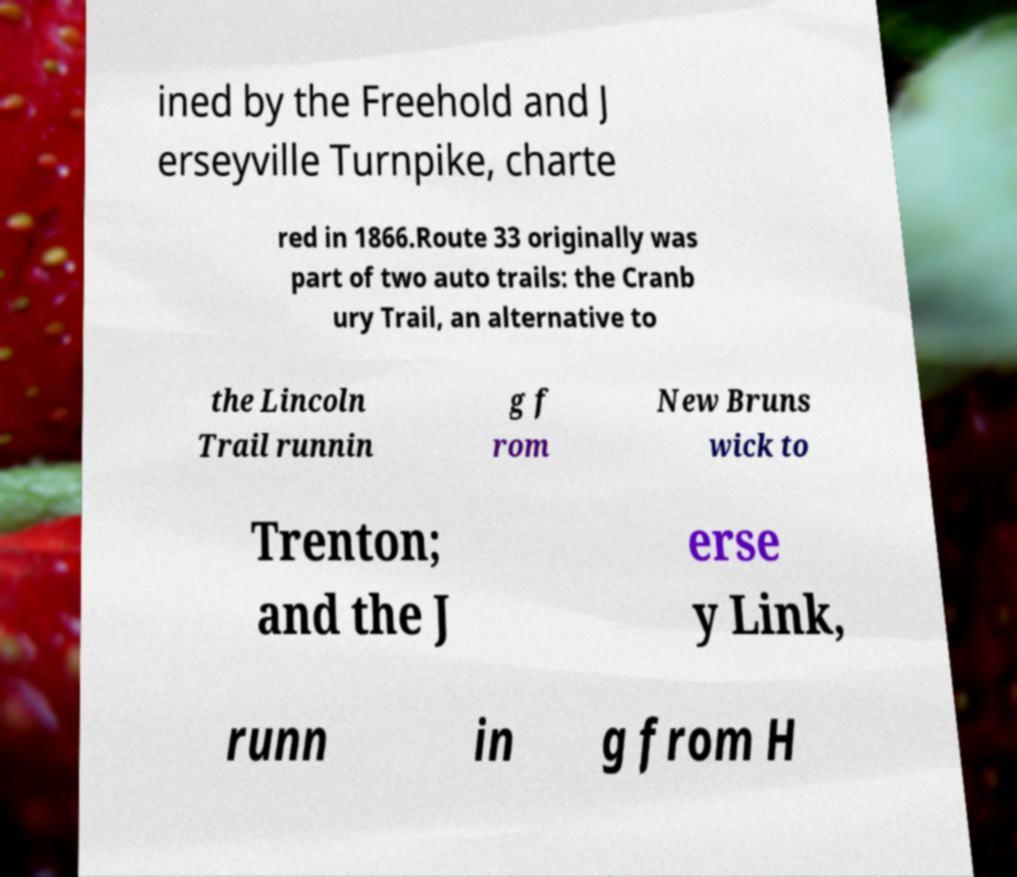What messages or text are displayed in this image? I need them in a readable, typed format. ined by the Freehold and J erseyville Turnpike, charte red in 1866.Route 33 originally was part of two auto trails: the Cranb ury Trail, an alternative to the Lincoln Trail runnin g f rom New Bruns wick to Trenton; and the J erse y Link, runn in g from H 